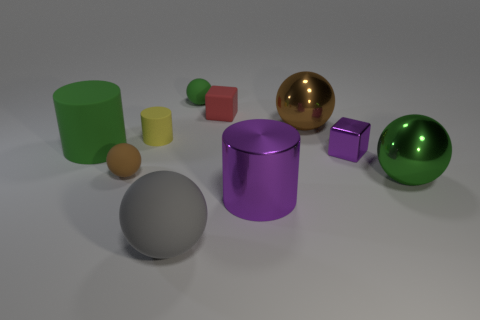Subtract all yellow rubber cylinders. How many cylinders are left? 2 Subtract all purple blocks. How many blocks are left? 1 Subtract all blue cubes. How many green balls are left? 2 Subtract all cylinders. How many objects are left? 7 Subtract 2 cylinders. How many cylinders are left? 1 Subtract 1 purple cylinders. How many objects are left? 9 Subtract all blue balls. Subtract all purple blocks. How many balls are left? 5 Subtract all small red matte cubes. Subtract all big gray matte spheres. How many objects are left? 8 Add 1 small purple things. How many small purple things are left? 2 Add 4 large rubber spheres. How many large rubber spheres exist? 5 